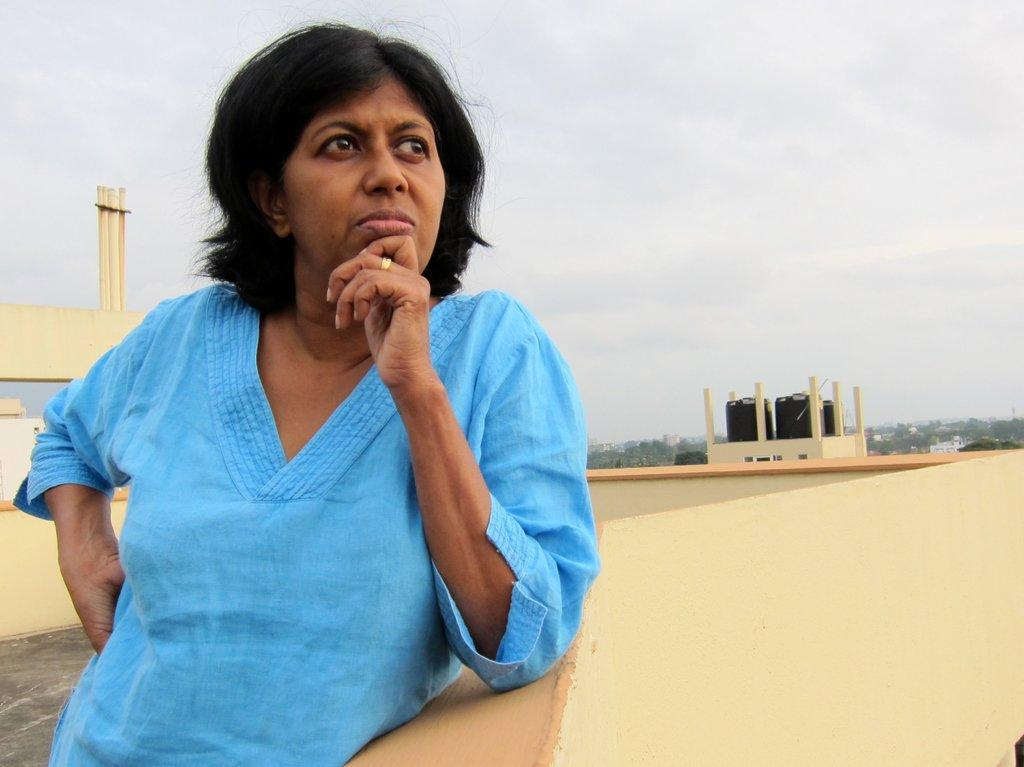Who is present in the image? There is a woman standing in the image. What structure can be seen in the background? There is a building in the image. What part of the natural environment is visible in the image? The sky is visible in the image. What type of receipt can be seen in the woman's hand in the image? There is no receipt present in the image; the woman's hands are not visible. 